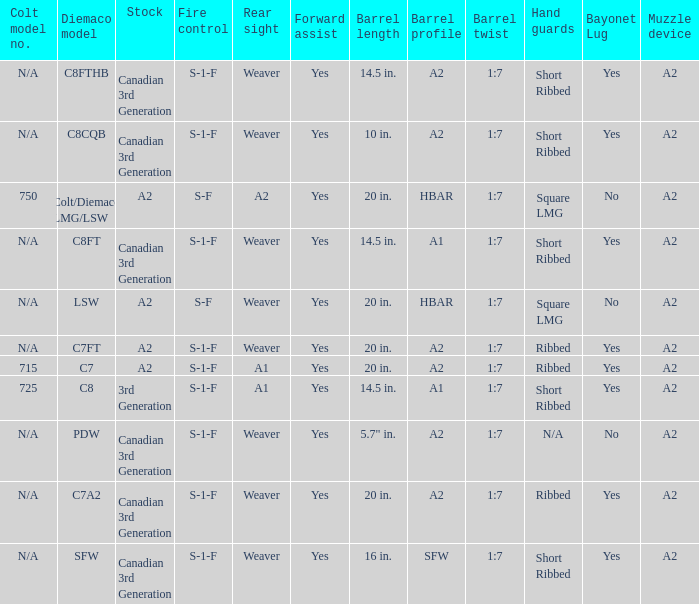Which Hand guards has a Barrel profile of a2 and a Rear sight of weaver? Ribbed, Ribbed, Short Ribbed, Short Ribbed, N/A. 